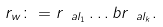<formula> <loc_0><loc_0><loc_500><loc_500>r _ { w } \colon = r _ { \ a l _ { 1 } } \dots b r _ { \ a l _ { k } } .</formula> 